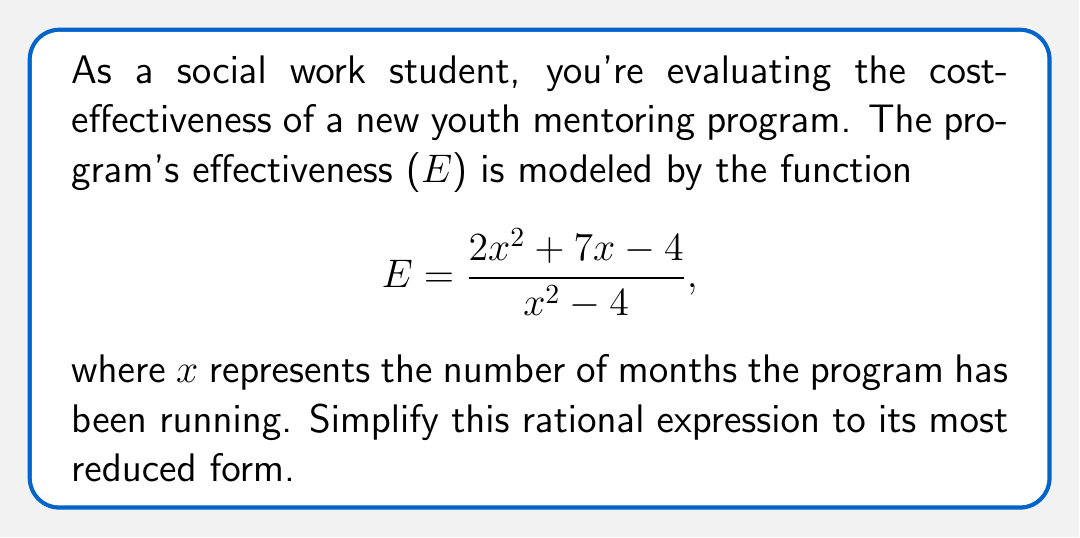Can you solve this math problem? Let's simplify this rational expression step by step:

1) First, we need to factor both the numerator and denominator:

   Numerator: $2x^2 + 7x - 4$
   This is a quadratic expression. We can factor it as:
   $$(2x-1)(x+4)$$

   Denominator: $x^2 - 4$
   This is a difference of squares. We can factor it as:
   $$(x+2)(x-2)$$

2) Now our expression looks like this:

   $$E = \frac{(2x-1)(x+4)}{(x+2)(x-2)}$$

3) We can see that $(x+4)$ appears in the numerator and $(x+2)$ appears in the denominator. These don't cancel out, so we can't simplify further.

4) Therefore, this is the most simplified form of the rational expression.
Answer: $$\frac{(2x-1)(x+4)}{(x+2)(x-2)}$$ 